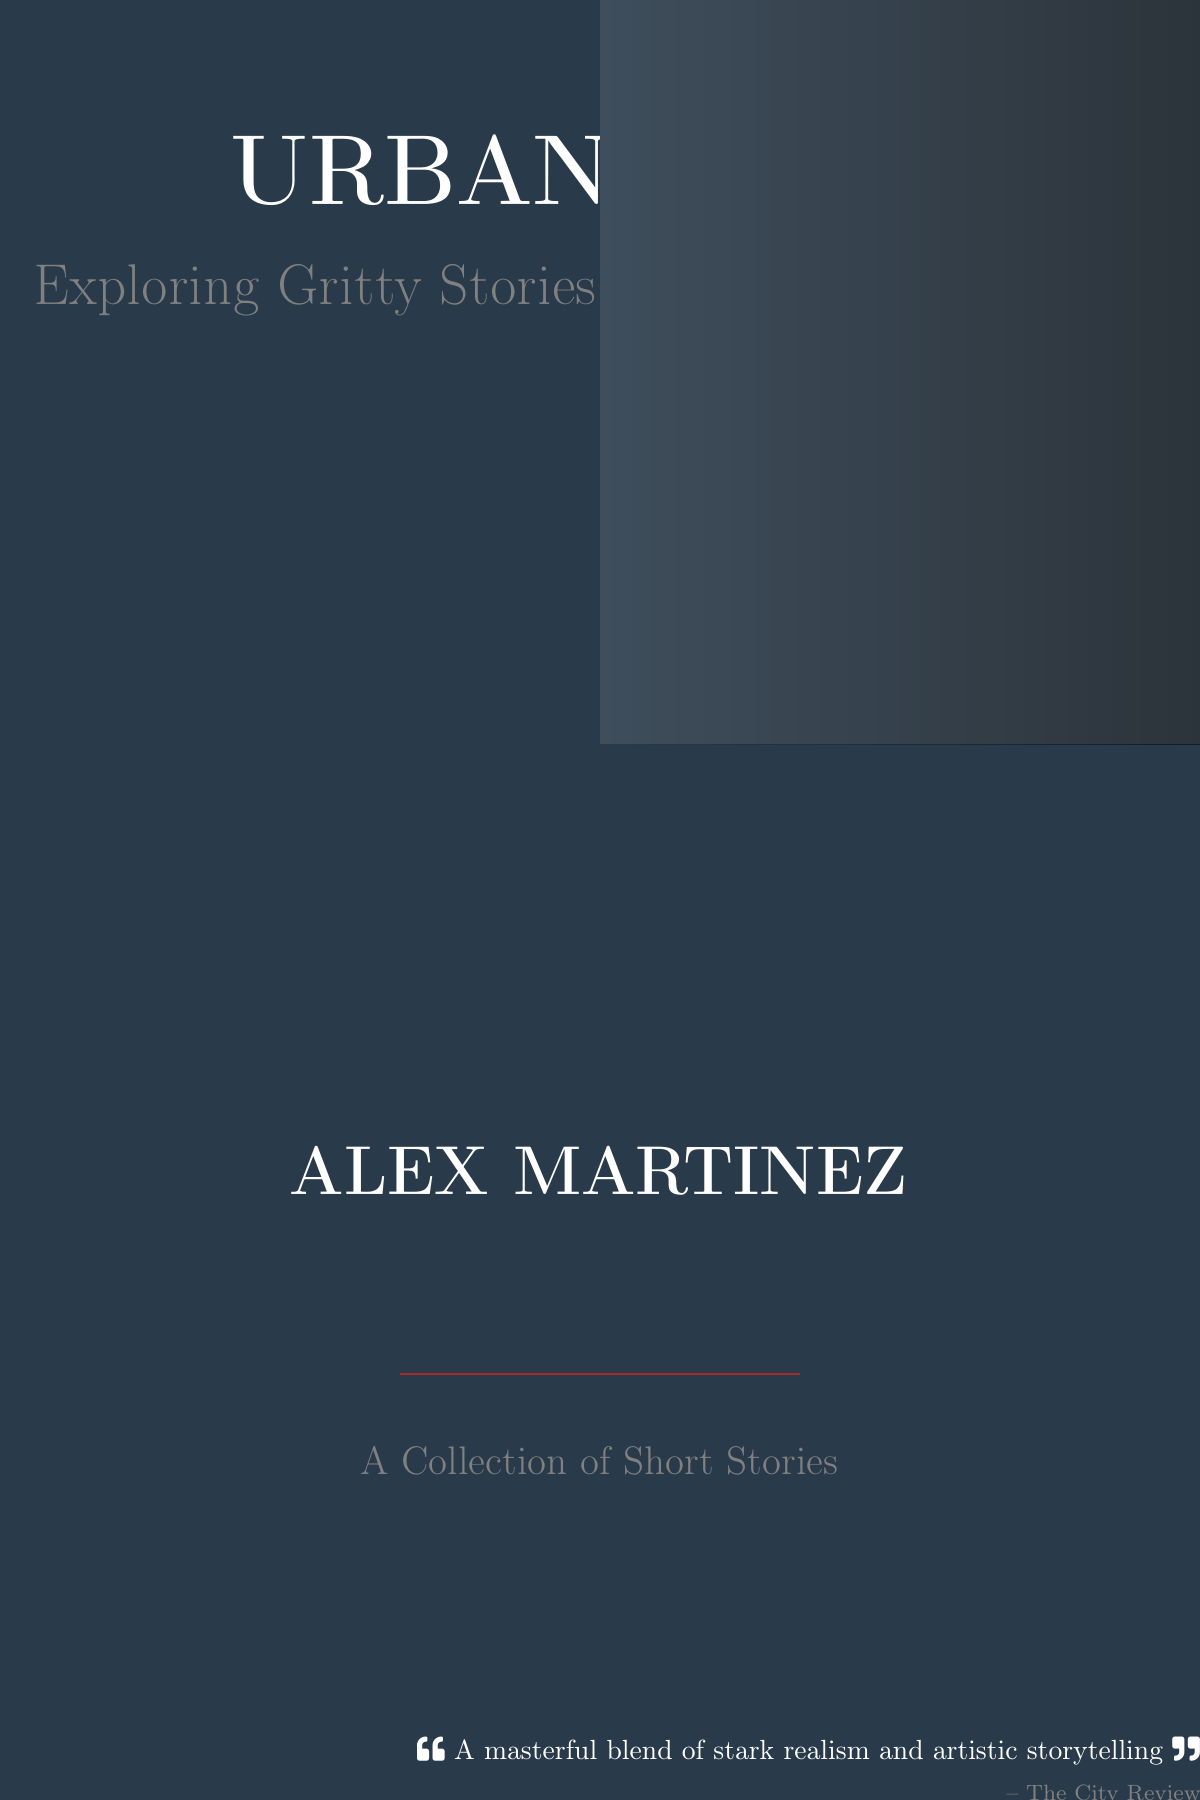What is the title of the book? The title is prominently displayed in large font, highlighting the main theme of the book.
Answer: URBAN TALES Who is the author of the book? The author's name is featured near the bottom of the cover, indicating their role in creating the content.
Answer: ALEX MARTINEZ What type of narrative does this book explore? The subtitle provides insight into the content and style of storytelling contained within.
Answer: Gritty stories How many short stories are in this collection? The description at the bottom indicates the nature of the contents included in the book.
Answer: A Collection of Short Stories What is the color of the background on the cover? The background color is evident and sets the mood for the book cover design.
Answer: Urban blue What review quote is included on the cover? A brief review at the bottom adds credibility and highlights the quality of the work.
Answer: A masterful blend of stark realism and artistic storytelling What color is used for the author's name? The author's name is printed in a color that stands out against the background.
Answer: White What visual element is used to enhance the cover design? The graphic design employs specific techniques to create depth and interest visually.
Answer: Dramatic use of shadows 